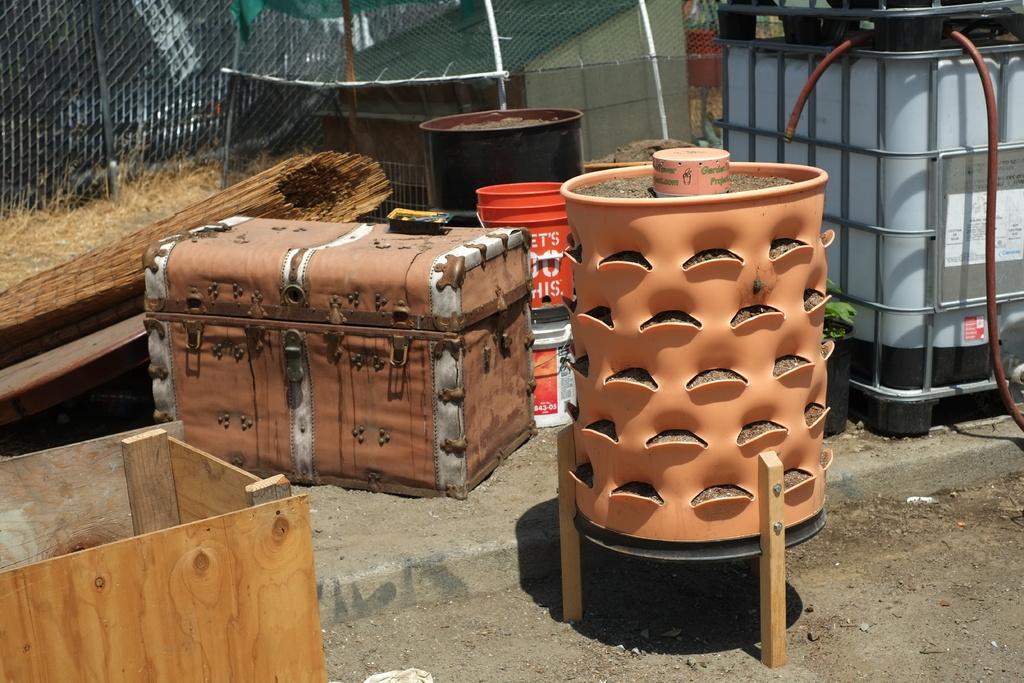Describe this image in one or two sentences. In the image there is a suitcase,bucket,fence in background at bottom there is a land with some stones. 